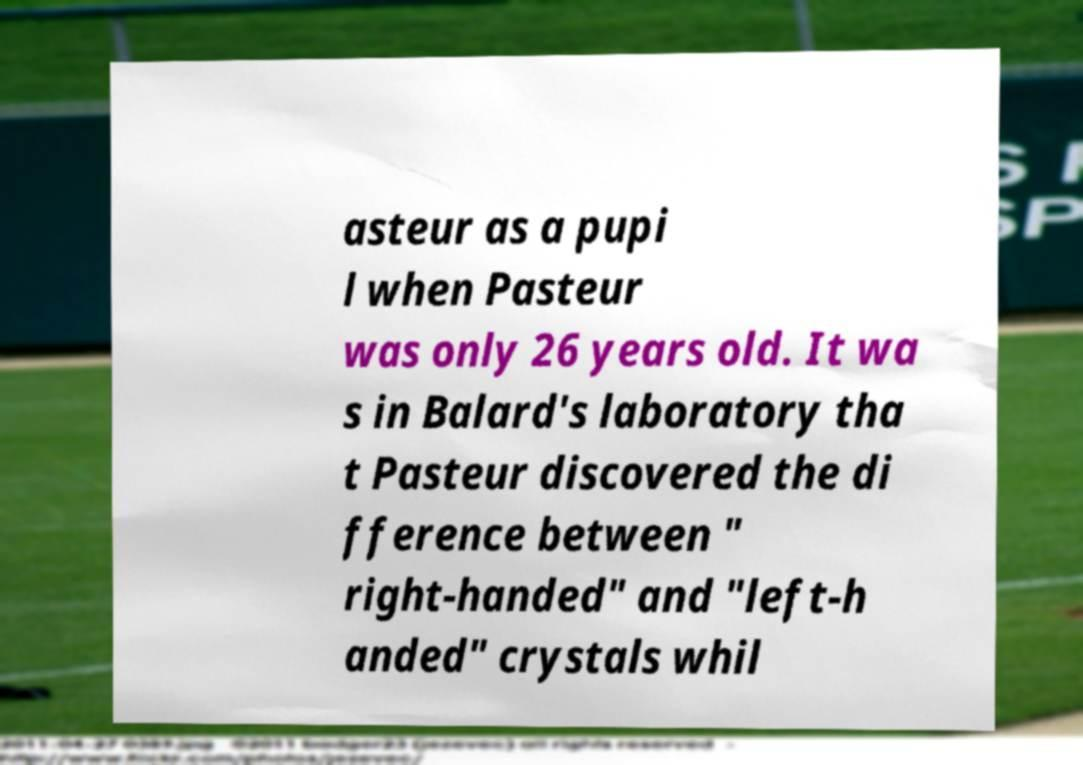Please identify and transcribe the text found in this image. asteur as a pupi l when Pasteur was only 26 years old. It wa s in Balard's laboratory tha t Pasteur discovered the di fference between " right-handed" and "left-h anded" crystals whil 